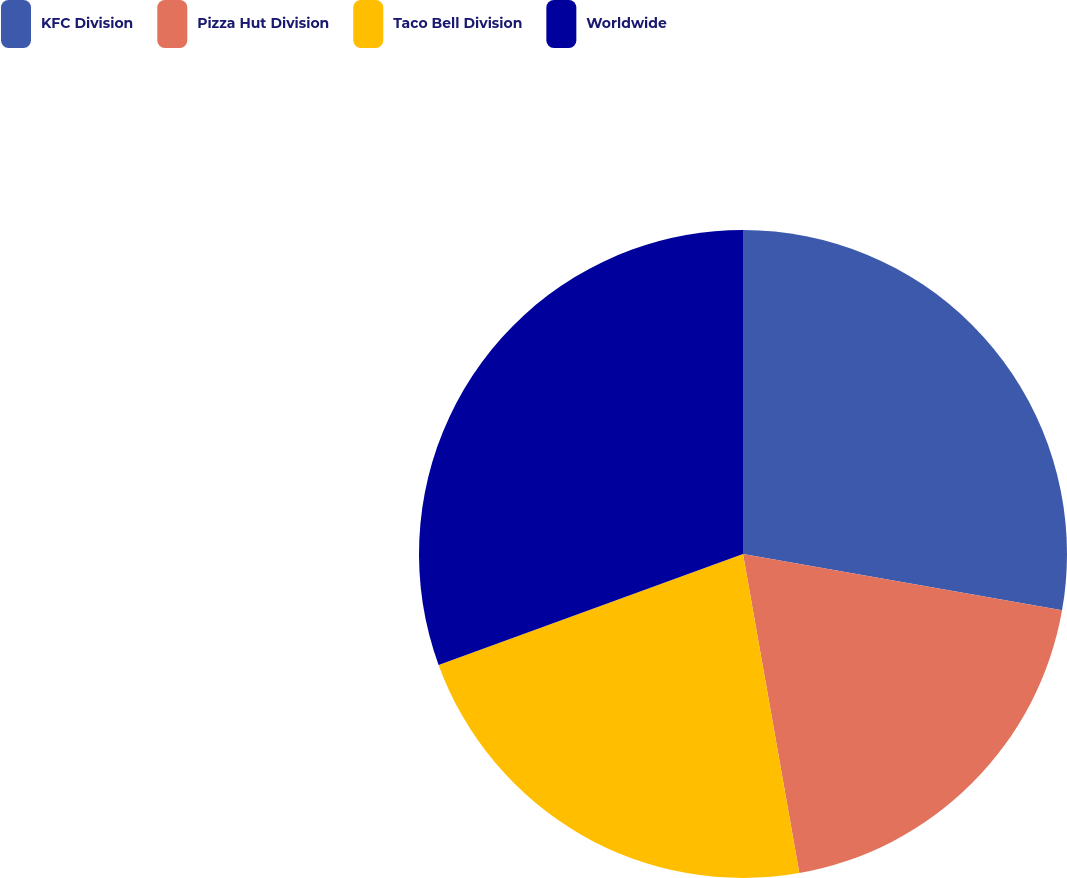Convert chart. <chart><loc_0><loc_0><loc_500><loc_500><pie_chart><fcel>KFC Division<fcel>Pizza Hut Division<fcel>Taco Bell Division<fcel>Worldwide<nl><fcel>27.78%<fcel>19.44%<fcel>22.22%<fcel>30.56%<nl></chart> 